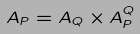<formula> <loc_0><loc_0><loc_500><loc_500>A _ { P } = A _ { Q } \times A _ { P } ^ { Q }</formula> 